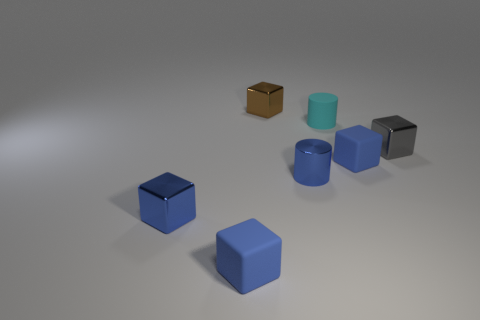Is the size of the cyan rubber cylinder the same as the metal object that is behind the gray metallic thing?
Offer a terse response. Yes. There is a matte block to the right of the small matte cube that is left of the matte cylinder; what color is it?
Offer a very short reply. Blue. Are there the same number of tiny cylinders that are behind the metallic cylinder and cyan cylinders in front of the cyan cylinder?
Ensure brevity in your answer.  No. Are the small cylinder that is in front of the small gray cube and the tiny brown object made of the same material?
Keep it short and to the point. Yes. What color is the tiny block that is both left of the cyan object and behind the blue cylinder?
Ensure brevity in your answer.  Brown. There is a blue cube to the right of the tiny brown block; what number of blue matte objects are in front of it?
Offer a very short reply. 1. What material is the gray thing that is the same shape as the tiny brown shiny object?
Give a very brief answer. Metal. What color is the shiny cylinder?
Give a very brief answer. Blue. What number of objects are blue metallic blocks or big yellow shiny objects?
Give a very brief answer. 1. There is a tiny rubber thing behind the blue cube to the right of the brown metallic thing; what shape is it?
Provide a succinct answer. Cylinder. 